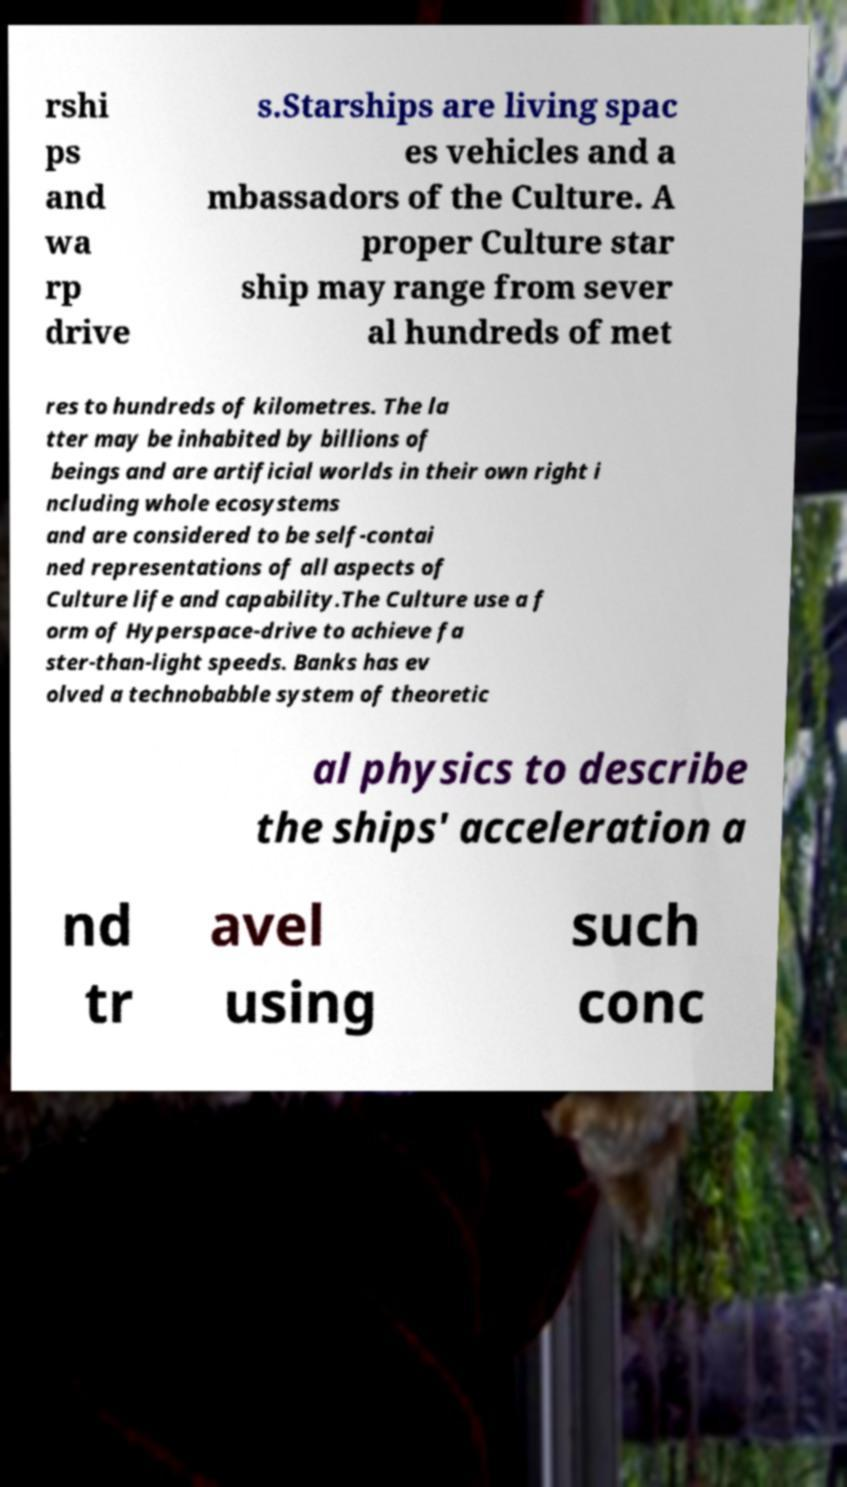For documentation purposes, I need the text within this image transcribed. Could you provide that? rshi ps and wa rp drive s.Starships are living spac es vehicles and a mbassadors of the Culture. A proper Culture star ship may range from sever al hundreds of met res to hundreds of kilometres. The la tter may be inhabited by billions of beings and are artificial worlds in their own right i ncluding whole ecosystems and are considered to be self-contai ned representations of all aspects of Culture life and capability.The Culture use a f orm of Hyperspace-drive to achieve fa ster-than-light speeds. Banks has ev olved a technobabble system of theoretic al physics to describe the ships' acceleration a nd tr avel using such conc 